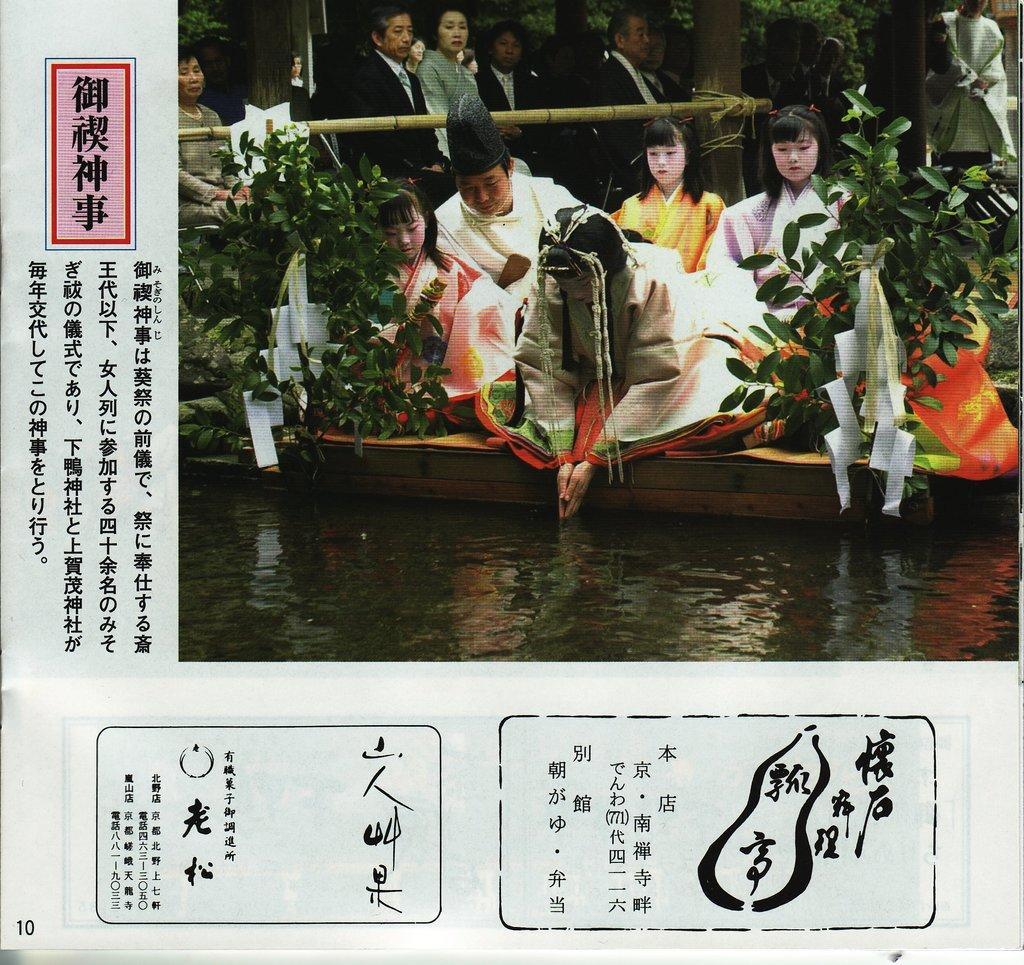Can you describe this image briefly? In this picture we can see group of people. This is water and there are plants. 